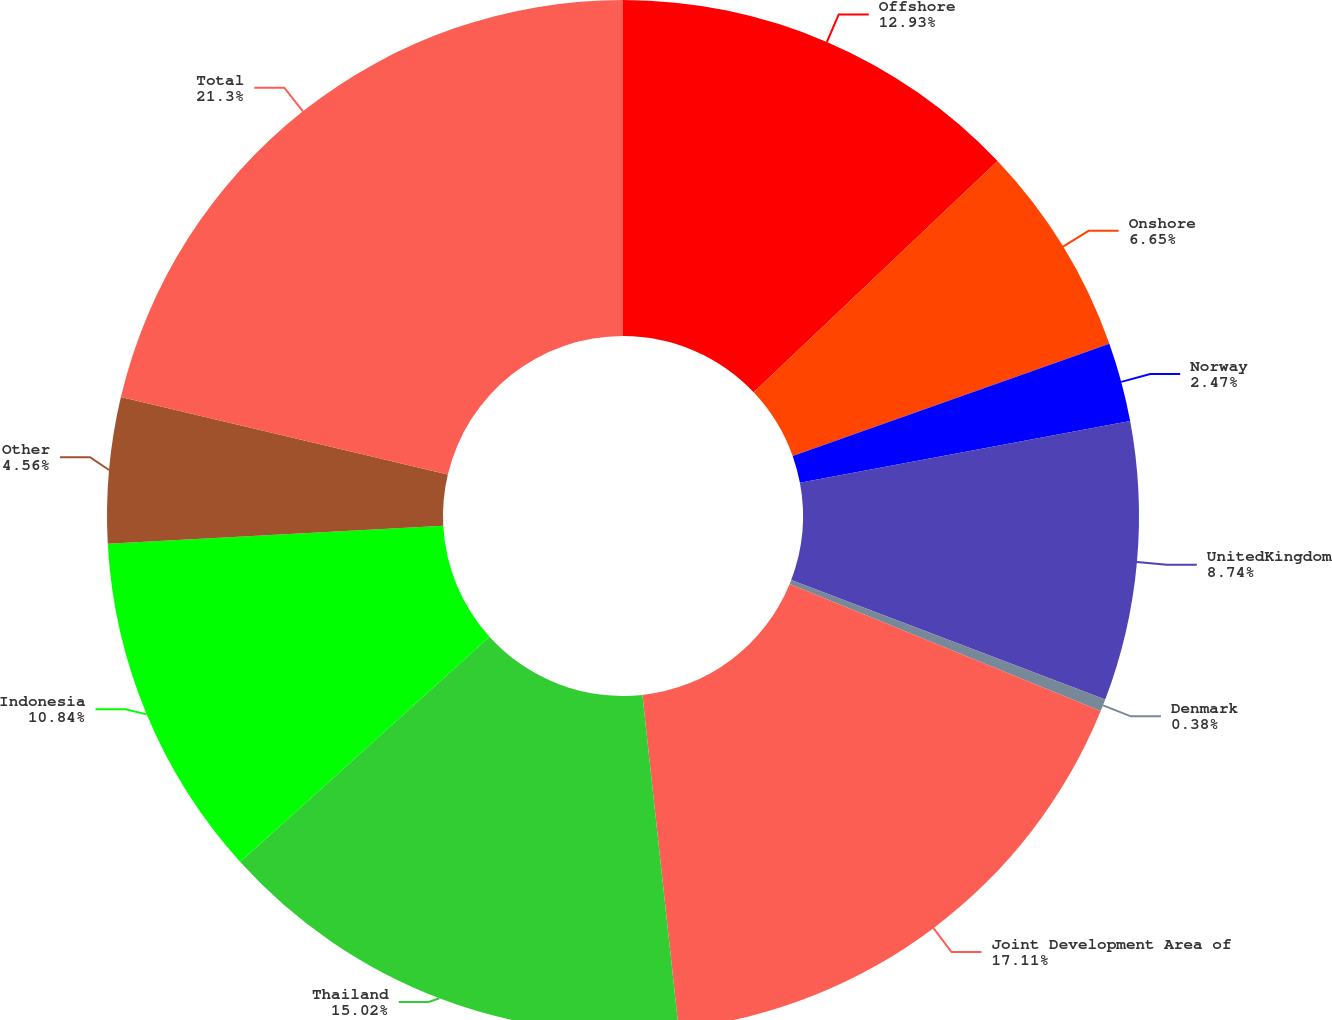Convert chart to OTSL. <chart><loc_0><loc_0><loc_500><loc_500><pie_chart><fcel>Offshore<fcel>Onshore<fcel>Norway<fcel>UnitedKingdom<fcel>Denmark<fcel>Joint Development Area of<fcel>Thailand<fcel>Indonesia<fcel>Other<fcel>Total<nl><fcel>12.93%<fcel>6.65%<fcel>2.47%<fcel>8.74%<fcel>0.38%<fcel>17.11%<fcel>15.02%<fcel>10.84%<fcel>4.56%<fcel>21.3%<nl></chart> 